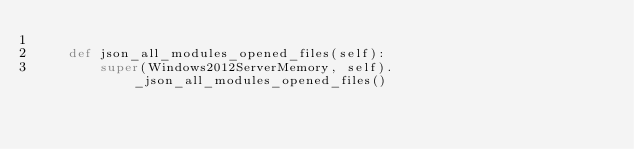Convert code to text. <code><loc_0><loc_0><loc_500><loc_500><_Python_>
    def json_all_modules_opened_files(self):
        super(Windows2012ServerMemory, self)._json_all_modules_opened_files()
</code> 